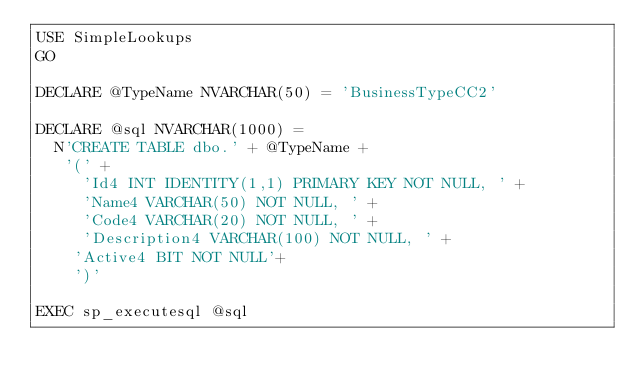Convert code to text. <code><loc_0><loc_0><loc_500><loc_500><_SQL_>USE SimpleLookups
GO

DECLARE @TypeName NVARCHAR(50) = 'BusinessTypeCC2'

DECLARE @sql NVARCHAR(1000) = 
	N'CREATE TABLE dbo.' + @TypeName + 
	 '(' + 
		 'Id4 INT IDENTITY(1,1) PRIMARY KEY NOT NULL, ' + 
		 'Name4 VARCHAR(50) NOT NULL, ' + 
		 'Code4 VARCHAR(20) NOT NULL, ' + 
		 'Description4 VARCHAR(100) NOT NULL, ' +
		'Active4 BIT NOT NULL'+
	  ')'

EXEC sp_executesql @sql</code> 